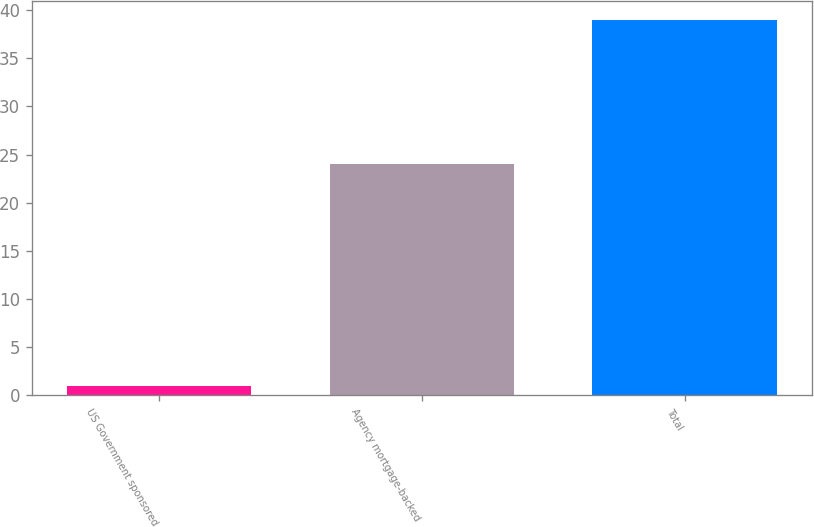<chart> <loc_0><loc_0><loc_500><loc_500><bar_chart><fcel>US Government sponsored<fcel>Agency mortgage-backed<fcel>Total<nl><fcel>1<fcel>24<fcel>39<nl></chart> 